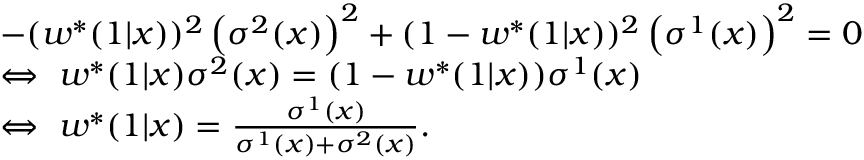<formula> <loc_0><loc_0><loc_500><loc_500>\begin{array} { r l } & { - ( w ^ { * } ( 1 | x ) ) ^ { 2 } \left ( \sigma ^ { 2 } ( x ) \right ) ^ { 2 } + ( 1 - w ^ { * } ( 1 | x ) ) ^ { 2 } \left ( \sigma ^ { 1 } ( x ) \right ) ^ { 2 } = 0 } \\ & { \Leftrightarrow \ w ^ { * } ( 1 | x ) \sigma ^ { 2 } ( x ) = ( 1 - w ^ { * } ( 1 | x ) ) \sigma ^ { 1 } ( x ) } \\ & { \Leftrightarrow \ w ^ { * } ( 1 | x ) = \frac { \sigma ^ { 1 } ( x ) } { \sigma ^ { 1 } ( x ) + \sigma ^ { 2 } ( x ) } . } \end{array}</formula> 